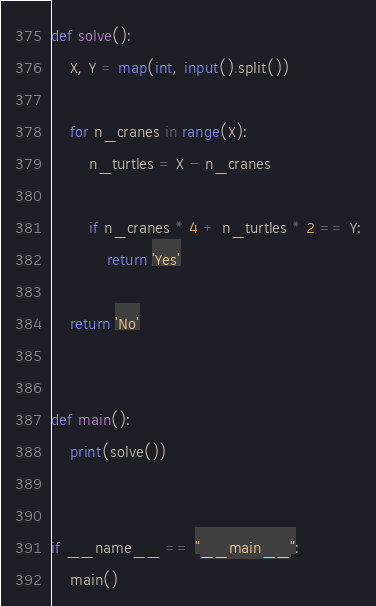Convert code to text. <code><loc_0><loc_0><loc_500><loc_500><_Python_>def solve():
    X, Y = map(int, input().split())

    for n_cranes in range(X):
        n_turtles = X - n_cranes

        if n_cranes * 4 + n_turtles * 2 == Y:
            return 'Yes'

    return 'No'


def main():
    print(solve())


if __name__ == "__main__":
    main()
</code> 